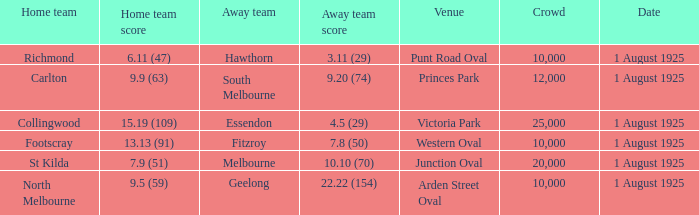When did the match take place that had a home team score of 7.9 (51)? 1 August 1925. 